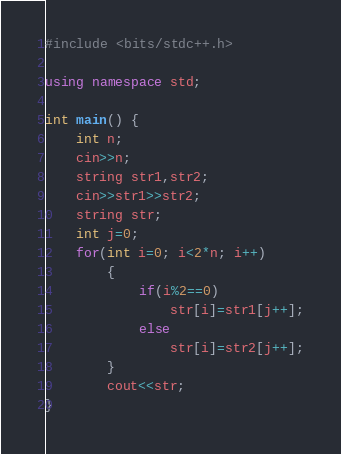<code> <loc_0><loc_0><loc_500><loc_500><_C++_>#include <bits/stdc++.h>

using namespace std;

int main() {
    int n;
    cin>>n;
    string str1,str2;
    cin>>str1>>str2;
    string str;
    int j=0;
    for(int i=0; i<2*n; i++)
        {
            if(i%2==0)
                str[i]=str1[j++];
            else
                str[i]=str2[j++];
        }
        cout<<str;
}
</code> 